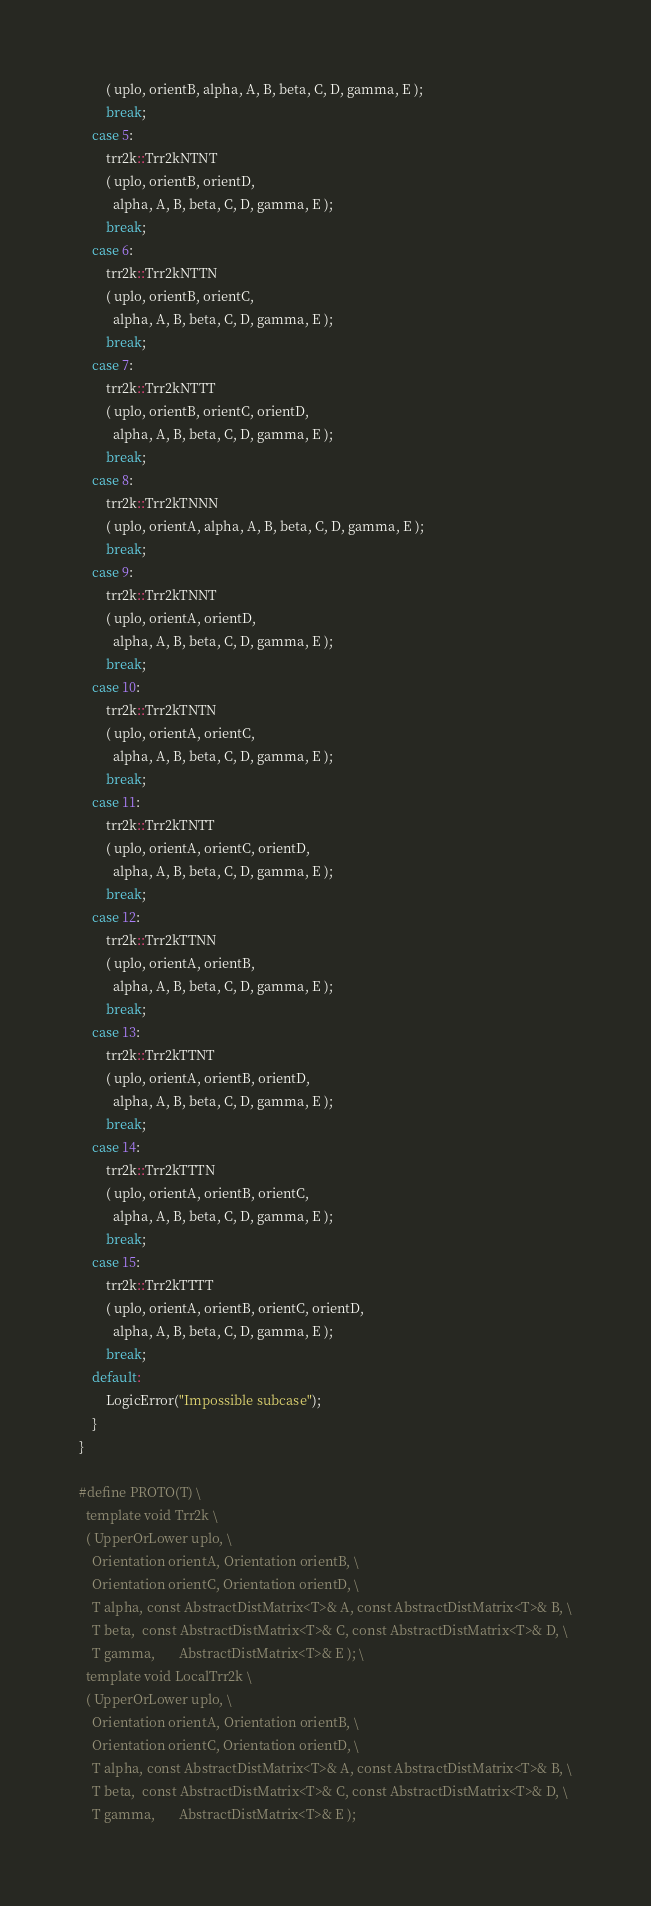<code> <loc_0><loc_0><loc_500><loc_500><_C++_>        ( uplo, orientB, alpha, A, B, beta, C, D, gamma, E );
        break;
    case 5:
        trr2k::Trr2kNTNT
        ( uplo, orientB, orientD, 
          alpha, A, B, beta, C, D, gamma, E );
        break;
    case 6:
        trr2k::Trr2kNTTN
        ( uplo, orientB, orientC, 
          alpha, A, B, beta, C, D, gamma, E );
        break;
    case 7:
        trr2k::Trr2kNTTT
        ( uplo, orientB, orientC, orientD, 
          alpha, A, B, beta, C, D, gamma, E );
        break;
    case 8:
        trr2k::Trr2kTNNN
        ( uplo, orientA, alpha, A, B, beta, C, D, gamma, E );
        break;
    case 9:
        trr2k::Trr2kTNNT
        ( uplo, orientA, orientD, 
          alpha, A, B, beta, C, D, gamma, E );
        break;
    case 10:
        trr2k::Trr2kTNTN
        ( uplo, orientA, orientC, 
          alpha, A, B, beta, C, D, gamma, E );
        break;
    case 11:
        trr2k::Trr2kTNTT
        ( uplo, orientA, orientC, orientD,
          alpha, A, B, beta, C, D, gamma, E );
        break;
    case 12:
        trr2k::Trr2kTTNN
        ( uplo, orientA, orientB, 
          alpha, A, B, beta, C, D, gamma, E );
        break;
    case 13:
        trr2k::Trr2kTTNT
        ( uplo, orientA, orientB, orientD,
          alpha, A, B, beta, C, D, gamma, E );
        break;
    case 14:
        trr2k::Trr2kTTTN
        ( uplo, orientA, orientB, orientC,
          alpha, A, B, beta, C, D, gamma, E );
        break;
    case 15:
        trr2k::Trr2kTTTT
        ( uplo, orientA, orientB, orientC, orientD,
          alpha, A, B, beta, C, D, gamma, E );
        break;
    default:
        LogicError("Impossible subcase");
    }
}

#define PROTO(T) \
  template void Trr2k \
  ( UpperOrLower uplo, \
    Orientation orientA, Orientation orientB, \
    Orientation orientC, Orientation orientD, \
    T alpha, const AbstractDistMatrix<T>& A, const AbstractDistMatrix<T>& B, \
    T beta,  const AbstractDistMatrix<T>& C, const AbstractDistMatrix<T>& D, \
    T gamma,       AbstractDistMatrix<T>& E ); \
  template void LocalTrr2k \
  ( UpperOrLower uplo, \
    Orientation orientA, Orientation orientB, \
    Orientation orientC, Orientation orientD, \
    T alpha, const AbstractDistMatrix<T>& A, const AbstractDistMatrix<T>& B, \
    T beta,  const AbstractDistMatrix<T>& C, const AbstractDistMatrix<T>& D, \
    T gamma,       AbstractDistMatrix<T>& E );
</code> 